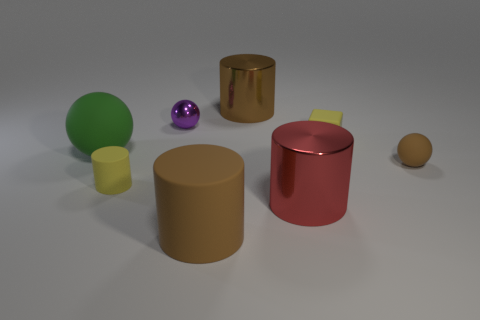Add 1 red things. How many objects exist? 9 Subtract all cubes. How many objects are left? 7 Subtract 0 gray cylinders. How many objects are left? 8 Subtract all large rubber cubes. Subtract all yellow matte blocks. How many objects are left? 7 Add 5 yellow rubber things. How many yellow rubber things are left? 7 Add 7 small yellow matte blocks. How many small yellow matte blocks exist? 8 